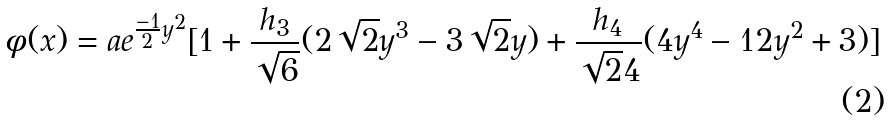Convert formula to latex. <formula><loc_0><loc_0><loc_500><loc_500>\phi ( x ) = a e ^ { \frac { - 1 } { 2 } y ^ { 2 } } [ 1 + \frac { h _ { 3 } } { \sqrt { 6 } } ( 2 \sqrt { 2 } y ^ { 3 } - 3 \sqrt { 2 } y ) + \frac { h _ { 4 } } { \sqrt { 2 } 4 } ( 4 y ^ { 4 } - 1 2 y ^ { 2 } + 3 ) ]</formula> 